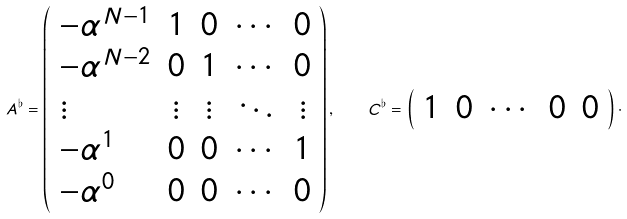Convert formula to latex. <formula><loc_0><loc_0><loc_500><loc_500>A ^ { \flat } = \left ( \begin{array} { l c c c c } - \alpha ^ { N - 1 } & 1 & 0 & \cdots & 0 \\ - \alpha ^ { N - 2 } & 0 & 1 & \cdots & 0 \\ \vdots & \vdots & \vdots & \ddots & \vdots \\ - \alpha ^ { 1 } & 0 & 0 & \cdots & 1 \\ - \alpha ^ { 0 } & 0 & 0 & \cdots & 0 \end{array} \right ) , \quad C ^ { \flat } = \left ( \begin{array} { c c c c c } 1 & 0 & \cdots & 0 & 0 \end{array} \right ) \cdot</formula> 